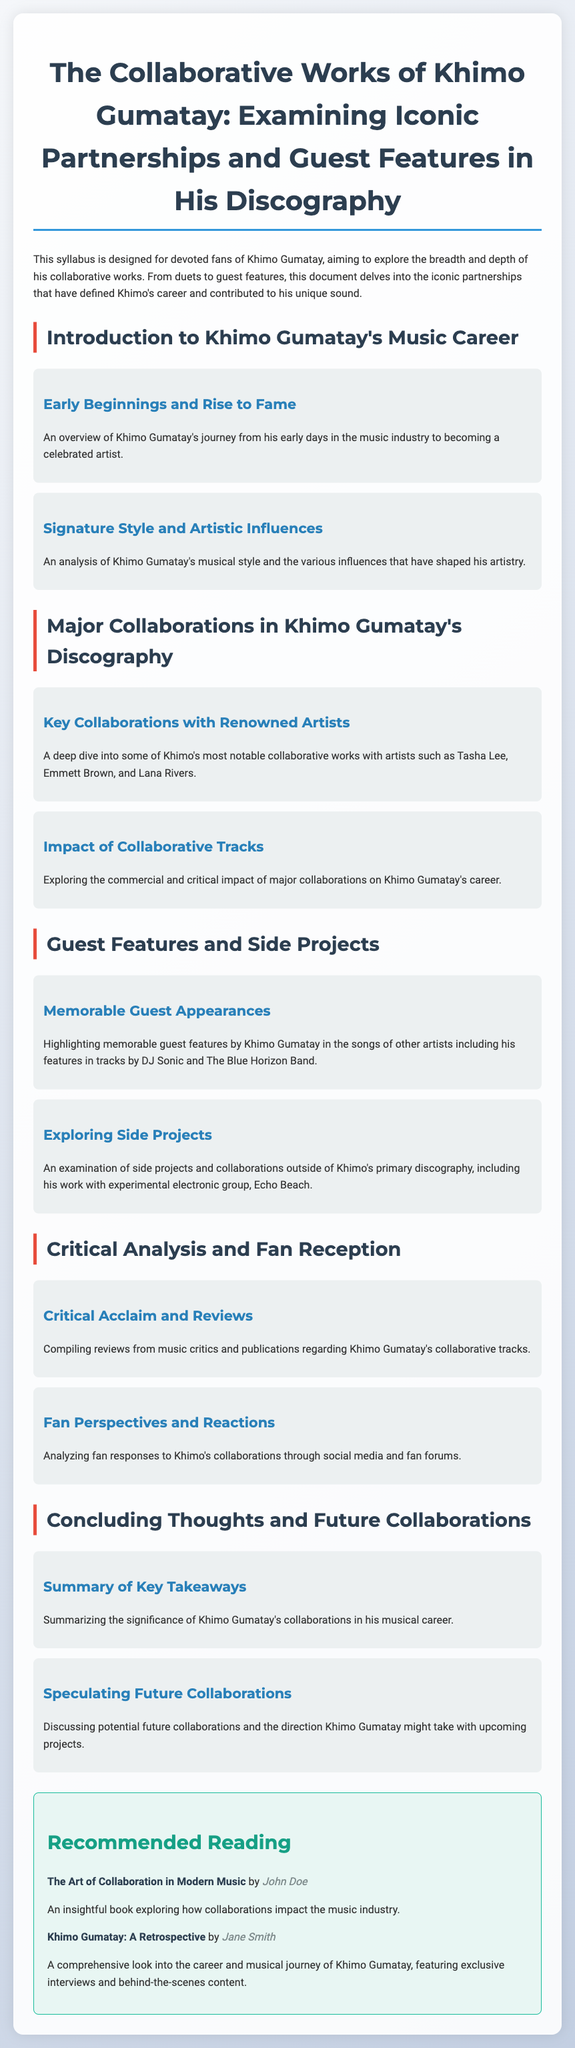What is the title of the syllabus? The title is mentioned at the top of the document, emphasizing the focus on Khimo Gumatay's collaborative works.
Answer: The Collaborative Works of Khimo Gumatay: Examining Iconic Partnerships and Guest Features in His Discography Who are two artists mentioned in Khimo's notable collaborations? The document highlights notable collaborations with specific artists, including Tasha Lee and Emmett Brown.
Answer: Tasha Lee, Emmett Brown What is one side project mentioned involving Khimo Gumatay? The syllabus refers to a specific side project that Khimo has worked on outside his main discography, specifically with a named group.
Answer: Echo Beach What section covers reviews from music critics? The document includes a section that compiles critical acclaim and reviews regarding Khimo's collaborative tracks.
Answer: Critical Acclaim and Reviews Which reading is recommended for exploring collaboration in modern music? A suggested book is listed in the recommended reading section, focusing on collaborations and their impact on the music industry.
Answer: The Art of Collaboration in Modern Music 